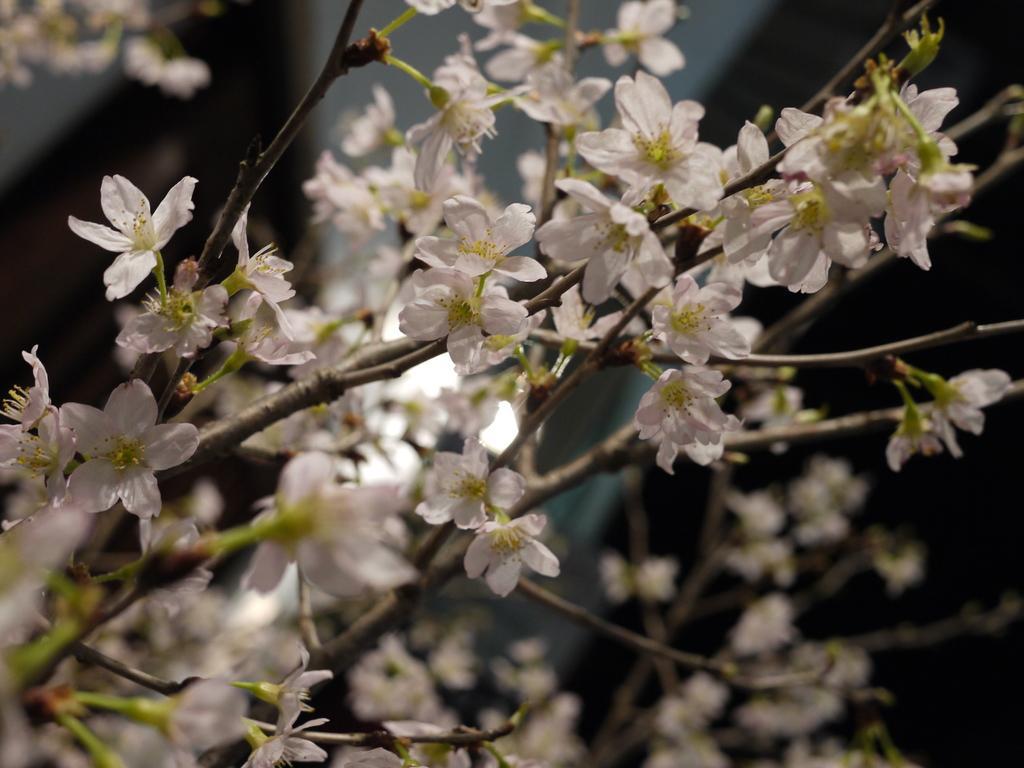Please provide a concise description of this image. This picture contains plants which have flowers. These flowers are in white color. In the background, it is blurred. 